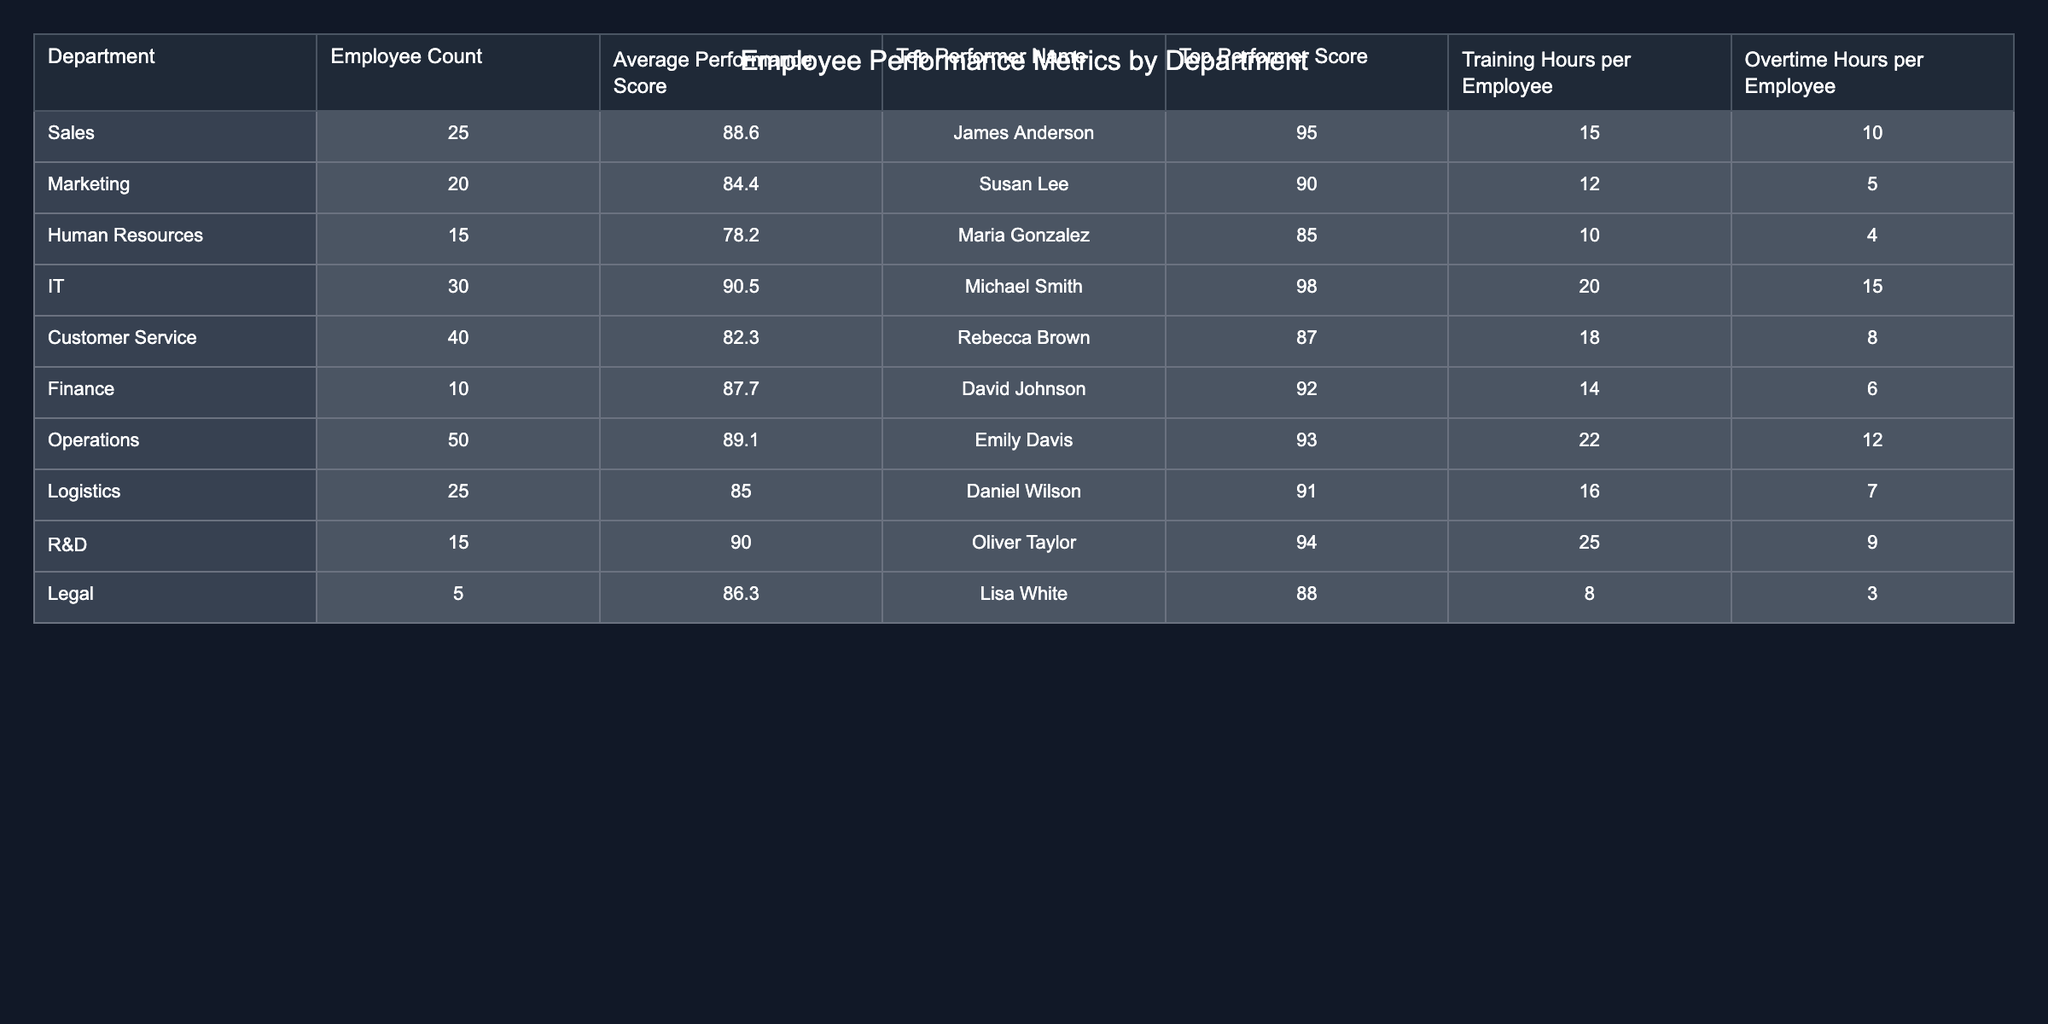What is the average performance score in the IT department? The average performance score for the IT department is directly provided in the table as 90.5.
Answer: 90.5 Who is the top performer in the Sales department? The top performer in the Sales department is listed as James Anderson with a score of 95.
Answer: James Anderson Which department has the highest average performance score? By comparing the average performance scores across departments, IT has the highest score of 90.5.
Answer: IT What is the total employee count across all departments? The total employee count can be obtained by summing the employee counts from each department: 25 + 20 + 15 + 30 + 40 + 10 + 50 + 25 + 15 + 5 = 230.
Answer: 230 Is the average performance score for Marketing greater than 85? The average performance score for Marketing is 84.4, which is not greater than 85, therefore the statement is false.
Answer: No What is the difference in training hours per employee between Operations and Human Resources? The training hours per employee for Operations is 22 and for Human Resources is 10. The difference is 22 - 10 = 12 hours.
Answer: 12 Which department has the least employee count and what is that count? Legal has the least employee count listed in the table at 5.
Answer: 5 If the average performance scores of Customer Service and Finance are combined, what is the sum? The average scores for Customer Service and Finance are 82.3 and 87.7 respectively. Adding them gives: 82.3 + 87.7 = 170.
Answer: 170 What is the total overtime hours per employee for the Logistics department? The table specifies that the overtime hours per employee in the Logistics department is 7.
Answer: 7 Which department has the lowest average performance score, and what is that score? Upon review, Human Resources has the lowest average performance score at 78.2.
Answer: 78.2 If R&D increased their training hours per employee to 30, what would be the new average training hours (assuming everything else stays the same)? Originally, R&D has 25 training hours per employee. If it increases to 30, the new value will simply be 30 as it’s a direct change.
Answer: 30 